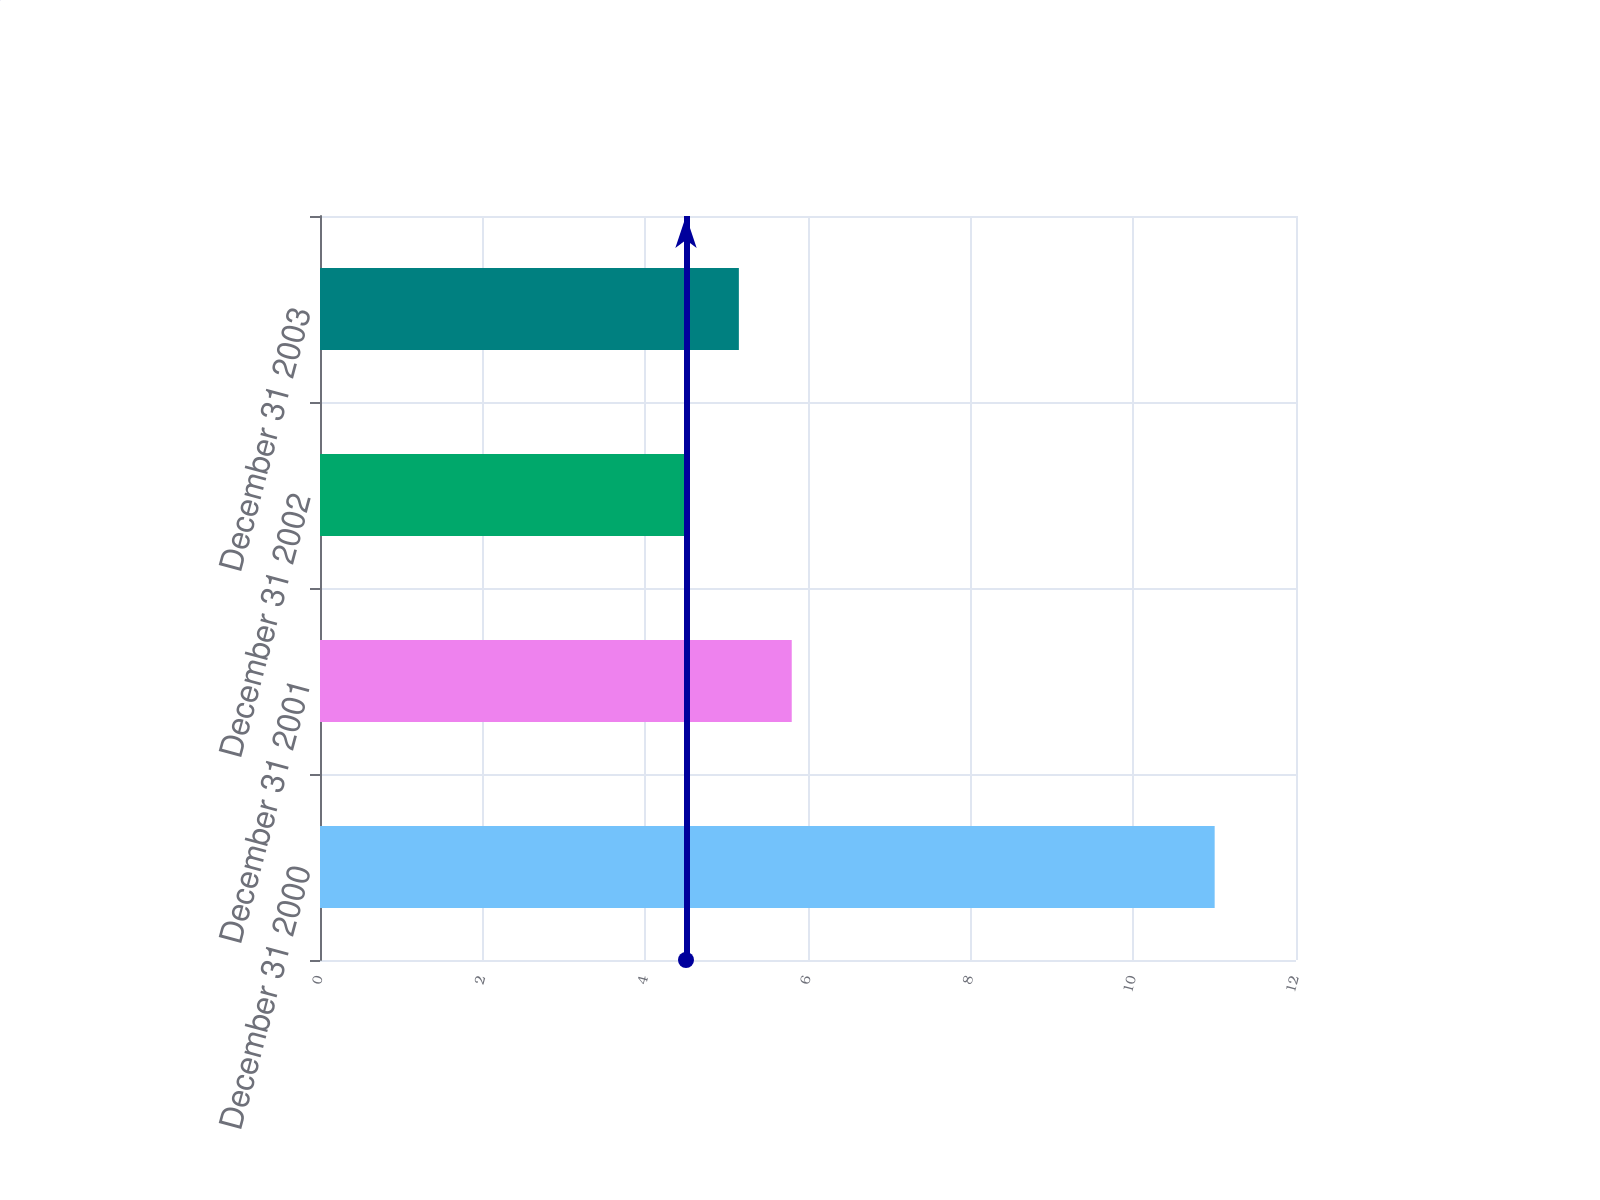<chart> <loc_0><loc_0><loc_500><loc_500><bar_chart><fcel>December 31 2000<fcel>December 31 2001<fcel>December 31 2002<fcel>December 31 2003<nl><fcel>11<fcel>5.8<fcel>4.5<fcel>5.15<nl></chart> 